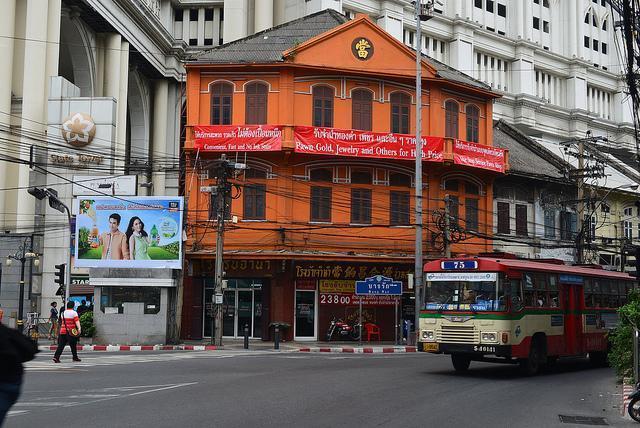How many stories is the orange building?
Give a very brief answer. 3. How many windows are open on the second floor?
Give a very brief answer. 0. 